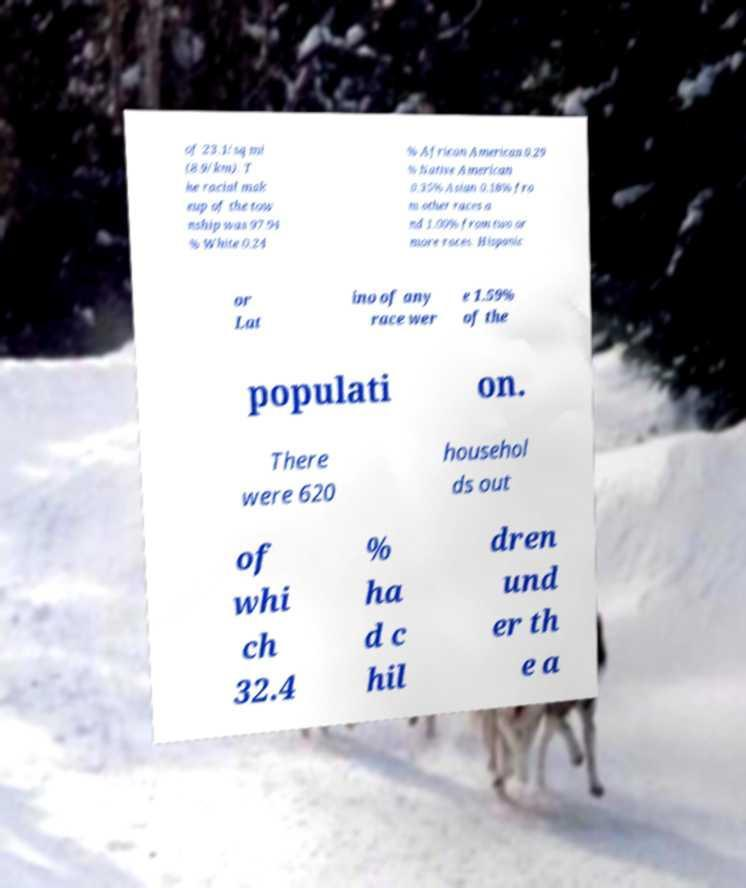Can you read and provide the text displayed in the image?This photo seems to have some interesting text. Can you extract and type it out for me? of 23.1/sq mi (8.9/km). T he racial mak eup of the tow nship was 97.94 % White 0.24 % African American 0.29 % Native American 0.35% Asian 0.18% fro m other races a nd 1.00% from two or more races. Hispanic or Lat ino of any race wer e 1.59% of the populati on. There were 620 househol ds out of whi ch 32.4 % ha d c hil dren und er th e a 